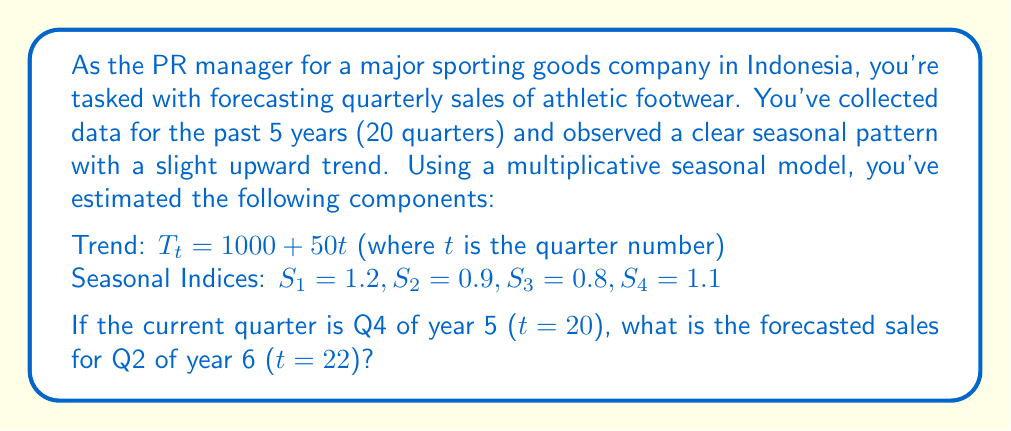Can you solve this math problem? To forecast the sales using a multiplicative seasonal model, we need to follow these steps:

1) The multiplicative model is given by:
   $Y_t = T_t \times S_t \times I_t$

   Where $Y_t$ is the forecasted value, $T_t$ is the trend component, $S_t$ is the seasonal component, and $I_t$ is the irregular component (which we assume to be 1 for forecasting).

2) Calculate the trend component for t = 22:
   $T_{22} = 1000 + 50(22) = 2100$

3) Identify the appropriate seasonal index. Since we're forecasting Q2, we use $S_2 = 0.9$

4) Apply the multiplicative model:
   $Y_{22} = T_{22} \times S_2 \times 1$
   $Y_{22} = 2100 \times 0.9 \times 1 = 1890$

Therefore, the forecasted sales for Q2 of year 6 is 1890 units.
Answer: 1890 units 